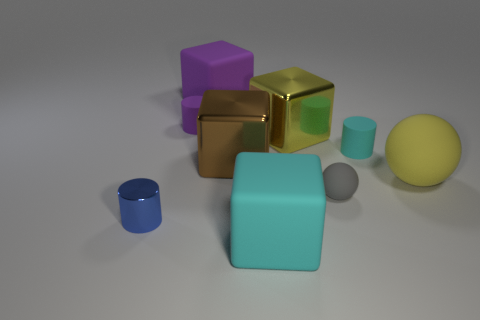Subtract 1 cubes. How many cubes are left? 3 Subtract all balls. How many objects are left? 7 Add 6 small matte objects. How many small matte objects exist? 9 Subtract 0 brown spheres. How many objects are left? 9 Subtract all large yellow shiny cubes. Subtract all gray objects. How many objects are left? 7 Add 6 big yellow rubber spheres. How many big yellow rubber spheres are left? 7 